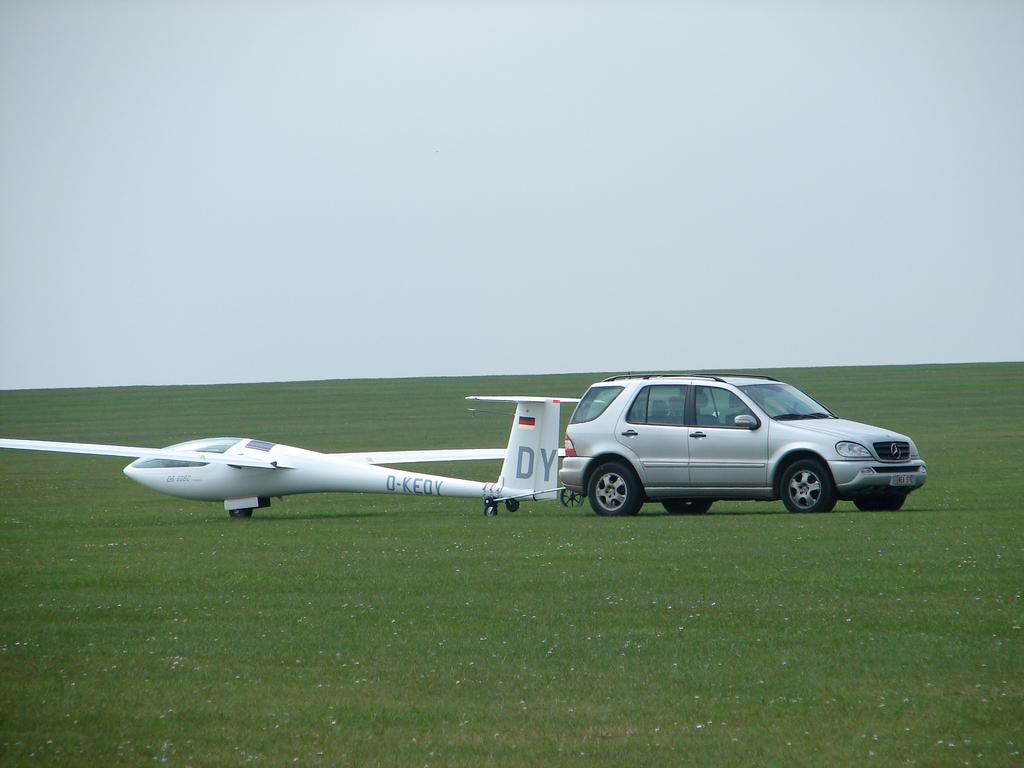Provide a one-sentence caption for the provided image. On the back of the drone plane, the letters "DY" appear. 